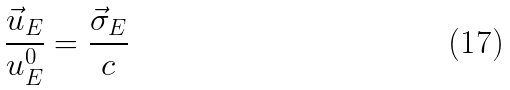Convert formula to latex. <formula><loc_0><loc_0><loc_500><loc_500>\frac { \vec { u } _ { E } } { u ^ { 0 } _ { E } } = \frac { \vec { \sigma } _ { E } } { c }</formula> 